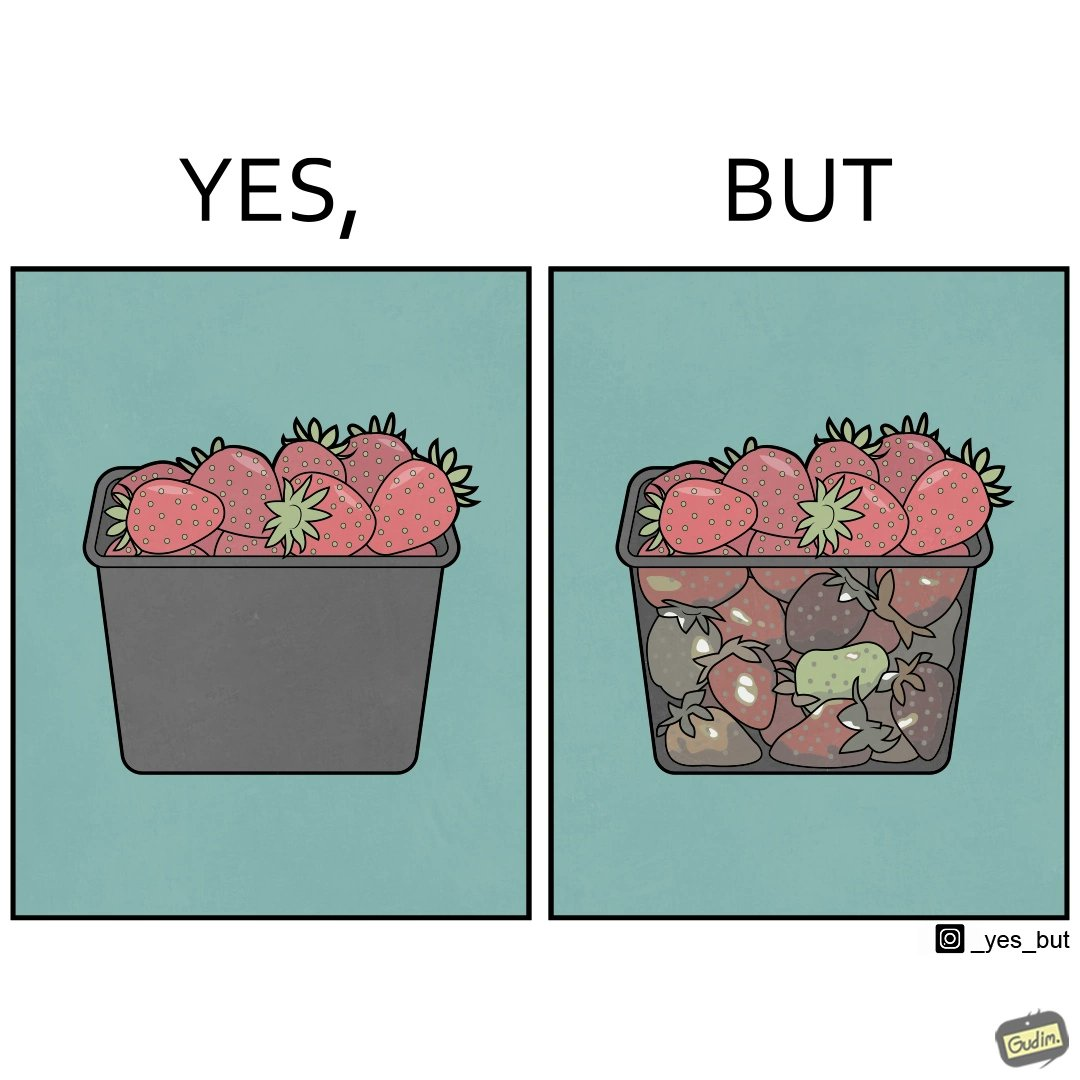What is shown in the left half versus the right half of this image? In the left part of the image: fresh strawberries in a container In the right part of the image: a container transparent from one of the sides, containing fresh strawberries at the top, and bad quality ones at the bottom. 